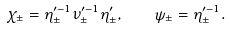<formula> <loc_0><loc_0><loc_500><loc_500>\chi _ { \pm } = \eta _ { \pm } ^ { \prime - 1 } \nu _ { \pm } ^ { \prime - 1 } \eta _ { \pm } ^ { \prime } , \quad \psi _ { \pm } = \eta _ { \pm } ^ { \prime - 1 } .</formula> 